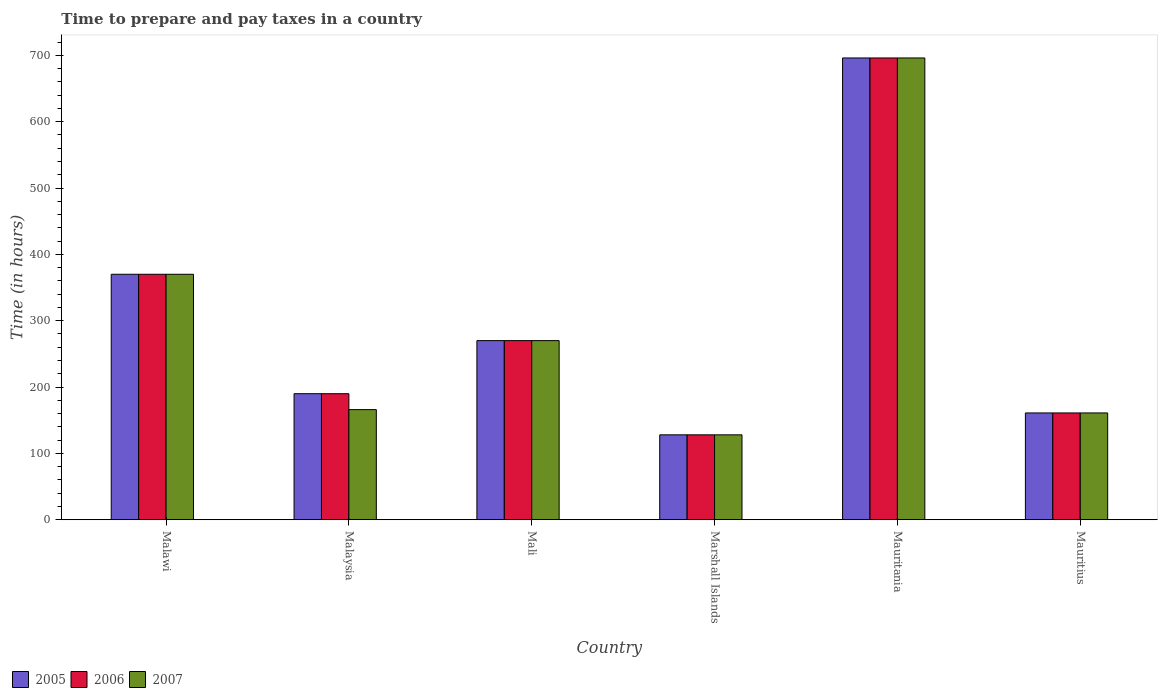How many groups of bars are there?
Your answer should be compact. 6. Are the number of bars on each tick of the X-axis equal?
Keep it short and to the point. Yes. How many bars are there on the 4th tick from the left?
Provide a short and direct response. 3. How many bars are there on the 6th tick from the right?
Your response must be concise. 3. What is the label of the 3rd group of bars from the left?
Your answer should be very brief. Mali. What is the number of hours required to prepare and pay taxes in 2006 in Marshall Islands?
Offer a very short reply. 128. Across all countries, what is the maximum number of hours required to prepare and pay taxes in 2006?
Give a very brief answer. 696. Across all countries, what is the minimum number of hours required to prepare and pay taxes in 2005?
Your answer should be very brief. 128. In which country was the number of hours required to prepare and pay taxes in 2007 maximum?
Offer a very short reply. Mauritania. In which country was the number of hours required to prepare and pay taxes in 2007 minimum?
Your response must be concise. Marshall Islands. What is the total number of hours required to prepare and pay taxes in 2006 in the graph?
Your answer should be compact. 1815. What is the difference between the number of hours required to prepare and pay taxes in 2007 in Mali and that in Mauritius?
Make the answer very short. 109. What is the average number of hours required to prepare and pay taxes in 2005 per country?
Your answer should be very brief. 302.5. What is the difference between the number of hours required to prepare and pay taxes of/in 2005 and number of hours required to prepare and pay taxes of/in 2006 in Mali?
Provide a short and direct response. 0. What is the ratio of the number of hours required to prepare and pay taxes in 2005 in Marshall Islands to that in Mauritius?
Keep it short and to the point. 0.8. What is the difference between the highest and the second highest number of hours required to prepare and pay taxes in 2006?
Offer a terse response. 326. What is the difference between the highest and the lowest number of hours required to prepare and pay taxes in 2007?
Offer a terse response. 568. Is the sum of the number of hours required to prepare and pay taxes in 2007 in Malawi and Mali greater than the maximum number of hours required to prepare and pay taxes in 2006 across all countries?
Offer a very short reply. No. What does the 3rd bar from the left in Mauritania represents?
Offer a terse response. 2007. Is it the case that in every country, the sum of the number of hours required to prepare and pay taxes in 2005 and number of hours required to prepare and pay taxes in 2007 is greater than the number of hours required to prepare and pay taxes in 2006?
Your answer should be compact. Yes. How many countries are there in the graph?
Provide a short and direct response. 6. What is the difference between two consecutive major ticks on the Y-axis?
Make the answer very short. 100. Are the values on the major ticks of Y-axis written in scientific E-notation?
Your response must be concise. No. Where does the legend appear in the graph?
Your answer should be compact. Bottom left. How many legend labels are there?
Your response must be concise. 3. How are the legend labels stacked?
Make the answer very short. Horizontal. What is the title of the graph?
Provide a succinct answer. Time to prepare and pay taxes in a country. What is the label or title of the X-axis?
Offer a very short reply. Country. What is the label or title of the Y-axis?
Your response must be concise. Time (in hours). What is the Time (in hours) in 2005 in Malawi?
Offer a terse response. 370. What is the Time (in hours) of 2006 in Malawi?
Provide a short and direct response. 370. What is the Time (in hours) of 2007 in Malawi?
Provide a short and direct response. 370. What is the Time (in hours) in 2005 in Malaysia?
Your response must be concise. 190. What is the Time (in hours) in 2006 in Malaysia?
Make the answer very short. 190. What is the Time (in hours) of 2007 in Malaysia?
Make the answer very short. 166. What is the Time (in hours) of 2005 in Mali?
Make the answer very short. 270. What is the Time (in hours) in 2006 in Mali?
Give a very brief answer. 270. What is the Time (in hours) in 2007 in Mali?
Offer a very short reply. 270. What is the Time (in hours) in 2005 in Marshall Islands?
Provide a short and direct response. 128. What is the Time (in hours) in 2006 in Marshall Islands?
Offer a terse response. 128. What is the Time (in hours) of 2007 in Marshall Islands?
Make the answer very short. 128. What is the Time (in hours) of 2005 in Mauritania?
Give a very brief answer. 696. What is the Time (in hours) in 2006 in Mauritania?
Keep it short and to the point. 696. What is the Time (in hours) of 2007 in Mauritania?
Provide a short and direct response. 696. What is the Time (in hours) in 2005 in Mauritius?
Give a very brief answer. 161. What is the Time (in hours) in 2006 in Mauritius?
Give a very brief answer. 161. What is the Time (in hours) in 2007 in Mauritius?
Provide a short and direct response. 161. Across all countries, what is the maximum Time (in hours) in 2005?
Keep it short and to the point. 696. Across all countries, what is the maximum Time (in hours) in 2006?
Your answer should be compact. 696. Across all countries, what is the maximum Time (in hours) of 2007?
Keep it short and to the point. 696. Across all countries, what is the minimum Time (in hours) in 2005?
Offer a very short reply. 128. Across all countries, what is the minimum Time (in hours) in 2006?
Make the answer very short. 128. Across all countries, what is the minimum Time (in hours) of 2007?
Your answer should be very brief. 128. What is the total Time (in hours) in 2005 in the graph?
Your response must be concise. 1815. What is the total Time (in hours) in 2006 in the graph?
Keep it short and to the point. 1815. What is the total Time (in hours) in 2007 in the graph?
Offer a very short reply. 1791. What is the difference between the Time (in hours) in 2005 in Malawi and that in Malaysia?
Offer a very short reply. 180. What is the difference between the Time (in hours) in 2006 in Malawi and that in Malaysia?
Provide a short and direct response. 180. What is the difference between the Time (in hours) in 2007 in Malawi and that in Malaysia?
Make the answer very short. 204. What is the difference between the Time (in hours) in 2006 in Malawi and that in Mali?
Ensure brevity in your answer.  100. What is the difference between the Time (in hours) of 2007 in Malawi and that in Mali?
Keep it short and to the point. 100. What is the difference between the Time (in hours) of 2005 in Malawi and that in Marshall Islands?
Your response must be concise. 242. What is the difference between the Time (in hours) in 2006 in Malawi and that in Marshall Islands?
Ensure brevity in your answer.  242. What is the difference between the Time (in hours) in 2007 in Malawi and that in Marshall Islands?
Your answer should be compact. 242. What is the difference between the Time (in hours) of 2005 in Malawi and that in Mauritania?
Provide a short and direct response. -326. What is the difference between the Time (in hours) in 2006 in Malawi and that in Mauritania?
Ensure brevity in your answer.  -326. What is the difference between the Time (in hours) of 2007 in Malawi and that in Mauritania?
Your answer should be compact. -326. What is the difference between the Time (in hours) of 2005 in Malawi and that in Mauritius?
Provide a succinct answer. 209. What is the difference between the Time (in hours) of 2006 in Malawi and that in Mauritius?
Offer a terse response. 209. What is the difference between the Time (in hours) of 2007 in Malawi and that in Mauritius?
Make the answer very short. 209. What is the difference between the Time (in hours) in 2005 in Malaysia and that in Mali?
Provide a short and direct response. -80. What is the difference between the Time (in hours) of 2006 in Malaysia and that in Mali?
Your answer should be compact. -80. What is the difference between the Time (in hours) in 2007 in Malaysia and that in Mali?
Your answer should be compact. -104. What is the difference between the Time (in hours) of 2006 in Malaysia and that in Marshall Islands?
Provide a succinct answer. 62. What is the difference between the Time (in hours) of 2007 in Malaysia and that in Marshall Islands?
Provide a succinct answer. 38. What is the difference between the Time (in hours) in 2005 in Malaysia and that in Mauritania?
Keep it short and to the point. -506. What is the difference between the Time (in hours) of 2006 in Malaysia and that in Mauritania?
Give a very brief answer. -506. What is the difference between the Time (in hours) of 2007 in Malaysia and that in Mauritania?
Provide a succinct answer. -530. What is the difference between the Time (in hours) in 2006 in Malaysia and that in Mauritius?
Your response must be concise. 29. What is the difference between the Time (in hours) in 2007 in Malaysia and that in Mauritius?
Provide a short and direct response. 5. What is the difference between the Time (in hours) of 2005 in Mali and that in Marshall Islands?
Keep it short and to the point. 142. What is the difference between the Time (in hours) of 2006 in Mali and that in Marshall Islands?
Provide a succinct answer. 142. What is the difference between the Time (in hours) of 2007 in Mali and that in Marshall Islands?
Offer a terse response. 142. What is the difference between the Time (in hours) in 2005 in Mali and that in Mauritania?
Offer a very short reply. -426. What is the difference between the Time (in hours) of 2006 in Mali and that in Mauritania?
Ensure brevity in your answer.  -426. What is the difference between the Time (in hours) in 2007 in Mali and that in Mauritania?
Ensure brevity in your answer.  -426. What is the difference between the Time (in hours) in 2005 in Mali and that in Mauritius?
Offer a very short reply. 109. What is the difference between the Time (in hours) in 2006 in Mali and that in Mauritius?
Your response must be concise. 109. What is the difference between the Time (in hours) in 2007 in Mali and that in Mauritius?
Offer a terse response. 109. What is the difference between the Time (in hours) of 2005 in Marshall Islands and that in Mauritania?
Your response must be concise. -568. What is the difference between the Time (in hours) of 2006 in Marshall Islands and that in Mauritania?
Make the answer very short. -568. What is the difference between the Time (in hours) of 2007 in Marshall Islands and that in Mauritania?
Provide a succinct answer. -568. What is the difference between the Time (in hours) in 2005 in Marshall Islands and that in Mauritius?
Your response must be concise. -33. What is the difference between the Time (in hours) in 2006 in Marshall Islands and that in Mauritius?
Offer a terse response. -33. What is the difference between the Time (in hours) in 2007 in Marshall Islands and that in Mauritius?
Provide a short and direct response. -33. What is the difference between the Time (in hours) of 2005 in Mauritania and that in Mauritius?
Your answer should be compact. 535. What is the difference between the Time (in hours) in 2006 in Mauritania and that in Mauritius?
Your response must be concise. 535. What is the difference between the Time (in hours) of 2007 in Mauritania and that in Mauritius?
Your answer should be very brief. 535. What is the difference between the Time (in hours) in 2005 in Malawi and the Time (in hours) in 2006 in Malaysia?
Provide a short and direct response. 180. What is the difference between the Time (in hours) in 2005 in Malawi and the Time (in hours) in 2007 in Malaysia?
Offer a terse response. 204. What is the difference between the Time (in hours) in 2006 in Malawi and the Time (in hours) in 2007 in Malaysia?
Give a very brief answer. 204. What is the difference between the Time (in hours) of 2005 in Malawi and the Time (in hours) of 2007 in Mali?
Provide a short and direct response. 100. What is the difference between the Time (in hours) of 2005 in Malawi and the Time (in hours) of 2006 in Marshall Islands?
Your answer should be very brief. 242. What is the difference between the Time (in hours) of 2005 in Malawi and the Time (in hours) of 2007 in Marshall Islands?
Provide a short and direct response. 242. What is the difference between the Time (in hours) of 2006 in Malawi and the Time (in hours) of 2007 in Marshall Islands?
Your answer should be compact. 242. What is the difference between the Time (in hours) in 2005 in Malawi and the Time (in hours) in 2006 in Mauritania?
Your response must be concise. -326. What is the difference between the Time (in hours) of 2005 in Malawi and the Time (in hours) of 2007 in Mauritania?
Provide a short and direct response. -326. What is the difference between the Time (in hours) in 2006 in Malawi and the Time (in hours) in 2007 in Mauritania?
Your answer should be compact. -326. What is the difference between the Time (in hours) of 2005 in Malawi and the Time (in hours) of 2006 in Mauritius?
Make the answer very short. 209. What is the difference between the Time (in hours) in 2005 in Malawi and the Time (in hours) in 2007 in Mauritius?
Your response must be concise. 209. What is the difference between the Time (in hours) of 2006 in Malawi and the Time (in hours) of 2007 in Mauritius?
Offer a very short reply. 209. What is the difference between the Time (in hours) in 2005 in Malaysia and the Time (in hours) in 2006 in Mali?
Ensure brevity in your answer.  -80. What is the difference between the Time (in hours) of 2005 in Malaysia and the Time (in hours) of 2007 in Mali?
Give a very brief answer. -80. What is the difference between the Time (in hours) of 2006 in Malaysia and the Time (in hours) of 2007 in Mali?
Ensure brevity in your answer.  -80. What is the difference between the Time (in hours) of 2005 in Malaysia and the Time (in hours) of 2007 in Marshall Islands?
Offer a terse response. 62. What is the difference between the Time (in hours) of 2005 in Malaysia and the Time (in hours) of 2006 in Mauritania?
Offer a terse response. -506. What is the difference between the Time (in hours) of 2005 in Malaysia and the Time (in hours) of 2007 in Mauritania?
Provide a short and direct response. -506. What is the difference between the Time (in hours) of 2006 in Malaysia and the Time (in hours) of 2007 in Mauritania?
Provide a short and direct response. -506. What is the difference between the Time (in hours) in 2005 in Malaysia and the Time (in hours) in 2006 in Mauritius?
Keep it short and to the point. 29. What is the difference between the Time (in hours) in 2006 in Malaysia and the Time (in hours) in 2007 in Mauritius?
Make the answer very short. 29. What is the difference between the Time (in hours) in 2005 in Mali and the Time (in hours) in 2006 in Marshall Islands?
Your answer should be very brief. 142. What is the difference between the Time (in hours) in 2005 in Mali and the Time (in hours) in 2007 in Marshall Islands?
Offer a very short reply. 142. What is the difference between the Time (in hours) of 2006 in Mali and the Time (in hours) of 2007 in Marshall Islands?
Offer a terse response. 142. What is the difference between the Time (in hours) of 2005 in Mali and the Time (in hours) of 2006 in Mauritania?
Provide a short and direct response. -426. What is the difference between the Time (in hours) of 2005 in Mali and the Time (in hours) of 2007 in Mauritania?
Your answer should be compact. -426. What is the difference between the Time (in hours) in 2006 in Mali and the Time (in hours) in 2007 in Mauritania?
Offer a terse response. -426. What is the difference between the Time (in hours) of 2005 in Mali and the Time (in hours) of 2006 in Mauritius?
Make the answer very short. 109. What is the difference between the Time (in hours) of 2005 in Mali and the Time (in hours) of 2007 in Mauritius?
Your response must be concise. 109. What is the difference between the Time (in hours) in 2006 in Mali and the Time (in hours) in 2007 in Mauritius?
Offer a terse response. 109. What is the difference between the Time (in hours) of 2005 in Marshall Islands and the Time (in hours) of 2006 in Mauritania?
Your answer should be very brief. -568. What is the difference between the Time (in hours) in 2005 in Marshall Islands and the Time (in hours) in 2007 in Mauritania?
Your response must be concise. -568. What is the difference between the Time (in hours) of 2006 in Marshall Islands and the Time (in hours) of 2007 in Mauritania?
Make the answer very short. -568. What is the difference between the Time (in hours) of 2005 in Marshall Islands and the Time (in hours) of 2006 in Mauritius?
Offer a terse response. -33. What is the difference between the Time (in hours) of 2005 in Marshall Islands and the Time (in hours) of 2007 in Mauritius?
Your answer should be very brief. -33. What is the difference between the Time (in hours) of 2006 in Marshall Islands and the Time (in hours) of 2007 in Mauritius?
Keep it short and to the point. -33. What is the difference between the Time (in hours) in 2005 in Mauritania and the Time (in hours) in 2006 in Mauritius?
Keep it short and to the point. 535. What is the difference between the Time (in hours) of 2005 in Mauritania and the Time (in hours) of 2007 in Mauritius?
Make the answer very short. 535. What is the difference between the Time (in hours) in 2006 in Mauritania and the Time (in hours) in 2007 in Mauritius?
Ensure brevity in your answer.  535. What is the average Time (in hours) of 2005 per country?
Your answer should be very brief. 302.5. What is the average Time (in hours) in 2006 per country?
Offer a very short reply. 302.5. What is the average Time (in hours) of 2007 per country?
Make the answer very short. 298.5. What is the difference between the Time (in hours) of 2005 and Time (in hours) of 2006 in Malawi?
Offer a terse response. 0. What is the difference between the Time (in hours) in 2005 and Time (in hours) in 2007 in Malawi?
Provide a succinct answer. 0. What is the difference between the Time (in hours) of 2005 and Time (in hours) of 2007 in Malaysia?
Keep it short and to the point. 24. What is the difference between the Time (in hours) of 2005 and Time (in hours) of 2006 in Mali?
Your answer should be very brief. 0. What is the difference between the Time (in hours) in 2005 and Time (in hours) in 2007 in Mali?
Offer a terse response. 0. What is the difference between the Time (in hours) in 2006 and Time (in hours) in 2007 in Mali?
Give a very brief answer. 0. What is the difference between the Time (in hours) of 2005 and Time (in hours) of 2007 in Mauritania?
Your response must be concise. 0. What is the difference between the Time (in hours) in 2005 and Time (in hours) in 2007 in Mauritius?
Give a very brief answer. 0. What is the ratio of the Time (in hours) of 2005 in Malawi to that in Malaysia?
Your answer should be compact. 1.95. What is the ratio of the Time (in hours) of 2006 in Malawi to that in Malaysia?
Ensure brevity in your answer.  1.95. What is the ratio of the Time (in hours) in 2007 in Malawi to that in Malaysia?
Offer a very short reply. 2.23. What is the ratio of the Time (in hours) of 2005 in Malawi to that in Mali?
Your response must be concise. 1.37. What is the ratio of the Time (in hours) in 2006 in Malawi to that in Mali?
Offer a very short reply. 1.37. What is the ratio of the Time (in hours) in 2007 in Malawi to that in Mali?
Your response must be concise. 1.37. What is the ratio of the Time (in hours) in 2005 in Malawi to that in Marshall Islands?
Provide a succinct answer. 2.89. What is the ratio of the Time (in hours) of 2006 in Malawi to that in Marshall Islands?
Keep it short and to the point. 2.89. What is the ratio of the Time (in hours) in 2007 in Malawi to that in Marshall Islands?
Your answer should be compact. 2.89. What is the ratio of the Time (in hours) of 2005 in Malawi to that in Mauritania?
Your response must be concise. 0.53. What is the ratio of the Time (in hours) of 2006 in Malawi to that in Mauritania?
Keep it short and to the point. 0.53. What is the ratio of the Time (in hours) in 2007 in Malawi to that in Mauritania?
Make the answer very short. 0.53. What is the ratio of the Time (in hours) of 2005 in Malawi to that in Mauritius?
Your answer should be compact. 2.3. What is the ratio of the Time (in hours) of 2006 in Malawi to that in Mauritius?
Keep it short and to the point. 2.3. What is the ratio of the Time (in hours) of 2007 in Malawi to that in Mauritius?
Ensure brevity in your answer.  2.3. What is the ratio of the Time (in hours) of 2005 in Malaysia to that in Mali?
Your answer should be compact. 0.7. What is the ratio of the Time (in hours) of 2006 in Malaysia to that in Mali?
Offer a very short reply. 0.7. What is the ratio of the Time (in hours) of 2007 in Malaysia to that in Mali?
Keep it short and to the point. 0.61. What is the ratio of the Time (in hours) in 2005 in Malaysia to that in Marshall Islands?
Your response must be concise. 1.48. What is the ratio of the Time (in hours) in 2006 in Malaysia to that in Marshall Islands?
Keep it short and to the point. 1.48. What is the ratio of the Time (in hours) of 2007 in Malaysia to that in Marshall Islands?
Provide a short and direct response. 1.3. What is the ratio of the Time (in hours) in 2005 in Malaysia to that in Mauritania?
Make the answer very short. 0.27. What is the ratio of the Time (in hours) of 2006 in Malaysia to that in Mauritania?
Your response must be concise. 0.27. What is the ratio of the Time (in hours) in 2007 in Malaysia to that in Mauritania?
Give a very brief answer. 0.24. What is the ratio of the Time (in hours) in 2005 in Malaysia to that in Mauritius?
Make the answer very short. 1.18. What is the ratio of the Time (in hours) of 2006 in Malaysia to that in Mauritius?
Ensure brevity in your answer.  1.18. What is the ratio of the Time (in hours) of 2007 in Malaysia to that in Mauritius?
Your answer should be compact. 1.03. What is the ratio of the Time (in hours) of 2005 in Mali to that in Marshall Islands?
Provide a succinct answer. 2.11. What is the ratio of the Time (in hours) of 2006 in Mali to that in Marshall Islands?
Your answer should be compact. 2.11. What is the ratio of the Time (in hours) in 2007 in Mali to that in Marshall Islands?
Keep it short and to the point. 2.11. What is the ratio of the Time (in hours) of 2005 in Mali to that in Mauritania?
Keep it short and to the point. 0.39. What is the ratio of the Time (in hours) of 2006 in Mali to that in Mauritania?
Provide a short and direct response. 0.39. What is the ratio of the Time (in hours) of 2007 in Mali to that in Mauritania?
Your response must be concise. 0.39. What is the ratio of the Time (in hours) of 2005 in Mali to that in Mauritius?
Provide a succinct answer. 1.68. What is the ratio of the Time (in hours) of 2006 in Mali to that in Mauritius?
Ensure brevity in your answer.  1.68. What is the ratio of the Time (in hours) of 2007 in Mali to that in Mauritius?
Your response must be concise. 1.68. What is the ratio of the Time (in hours) in 2005 in Marshall Islands to that in Mauritania?
Your answer should be very brief. 0.18. What is the ratio of the Time (in hours) in 2006 in Marshall Islands to that in Mauritania?
Provide a short and direct response. 0.18. What is the ratio of the Time (in hours) of 2007 in Marshall Islands to that in Mauritania?
Make the answer very short. 0.18. What is the ratio of the Time (in hours) of 2005 in Marshall Islands to that in Mauritius?
Your answer should be very brief. 0.8. What is the ratio of the Time (in hours) in 2006 in Marshall Islands to that in Mauritius?
Provide a short and direct response. 0.8. What is the ratio of the Time (in hours) of 2007 in Marshall Islands to that in Mauritius?
Your answer should be compact. 0.8. What is the ratio of the Time (in hours) in 2005 in Mauritania to that in Mauritius?
Offer a very short reply. 4.32. What is the ratio of the Time (in hours) in 2006 in Mauritania to that in Mauritius?
Offer a terse response. 4.32. What is the ratio of the Time (in hours) of 2007 in Mauritania to that in Mauritius?
Your response must be concise. 4.32. What is the difference between the highest and the second highest Time (in hours) in 2005?
Make the answer very short. 326. What is the difference between the highest and the second highest Time (in hours) of 2006?
Your answer should be compact. 326. What is the difference between the highest and the second highest Time (in hours) of 2007?
Your answer should be compact. 326. What is the difference between the highest and the lowest Time (in hours) of 2005?
Ensure brevity in your answer.  568. What is the difference between the highest and the lowest Time (in hours) of 2006?
Ensure brevity in your answer.  568. What is the difference between the highest and the lowest Time (in hours) of 2007?
Provide a succinct answer. 568. 